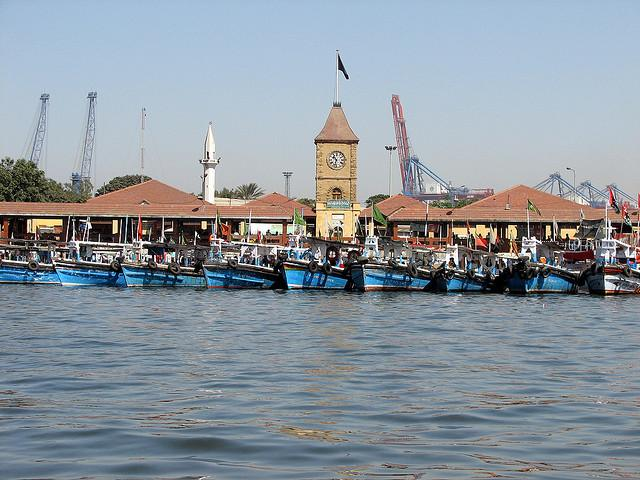What except for a flag are the highest emanations coming from here?

Choices:
A) homes
B) cranes
C) boats
D) bridges cranes 